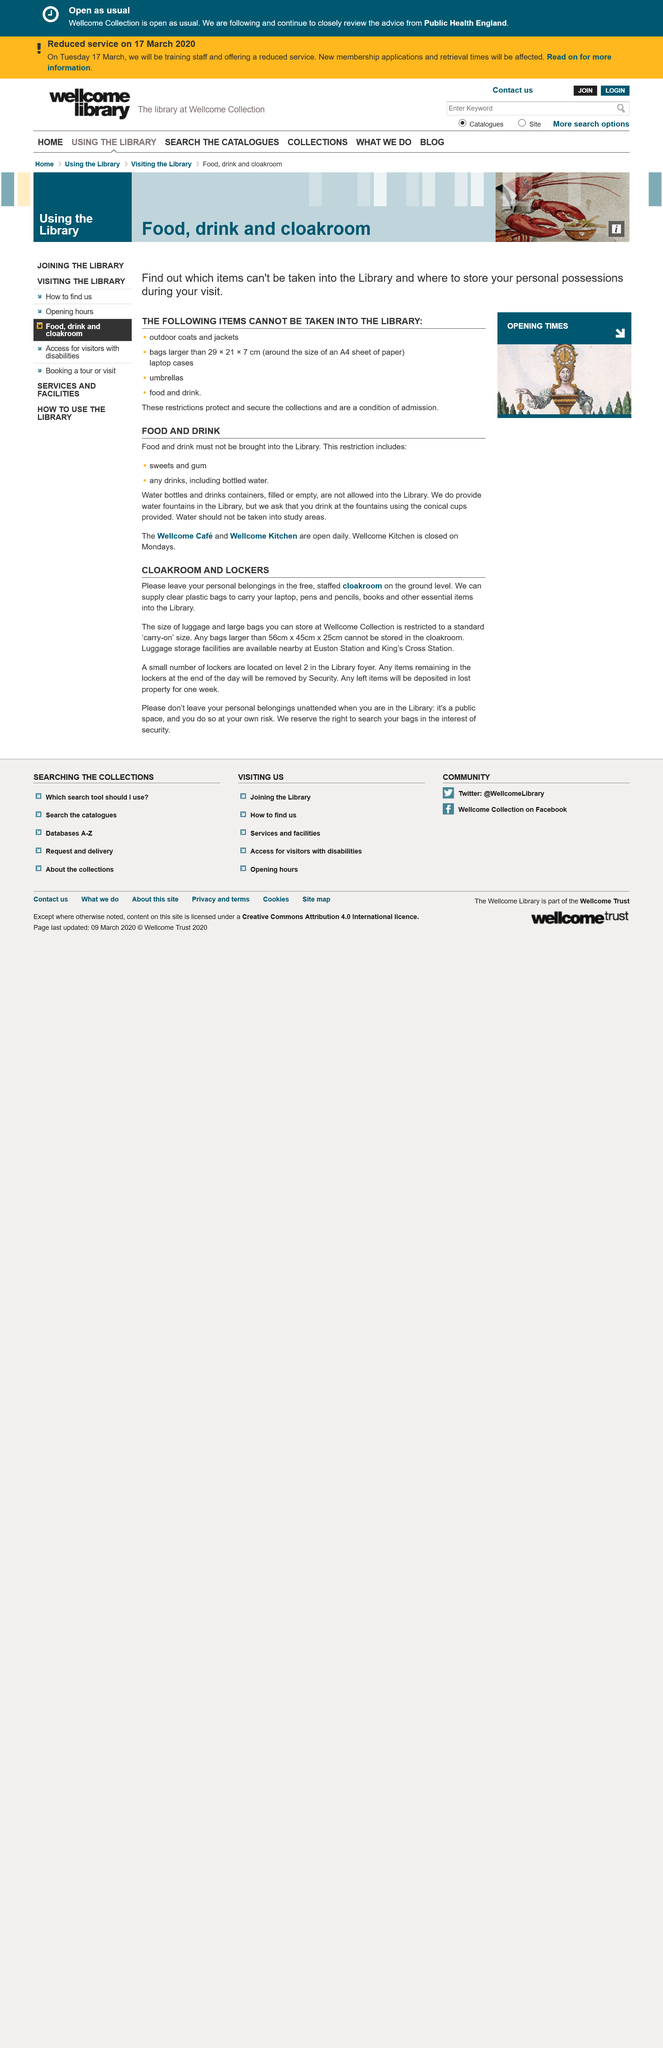Indicate a few pertinent items in this graphic. Clear plastic bags are essential for carrying essential items. The staffed cloakroom is located on the ground floor. The lockers can be found on level 2 in the Library foyer. 